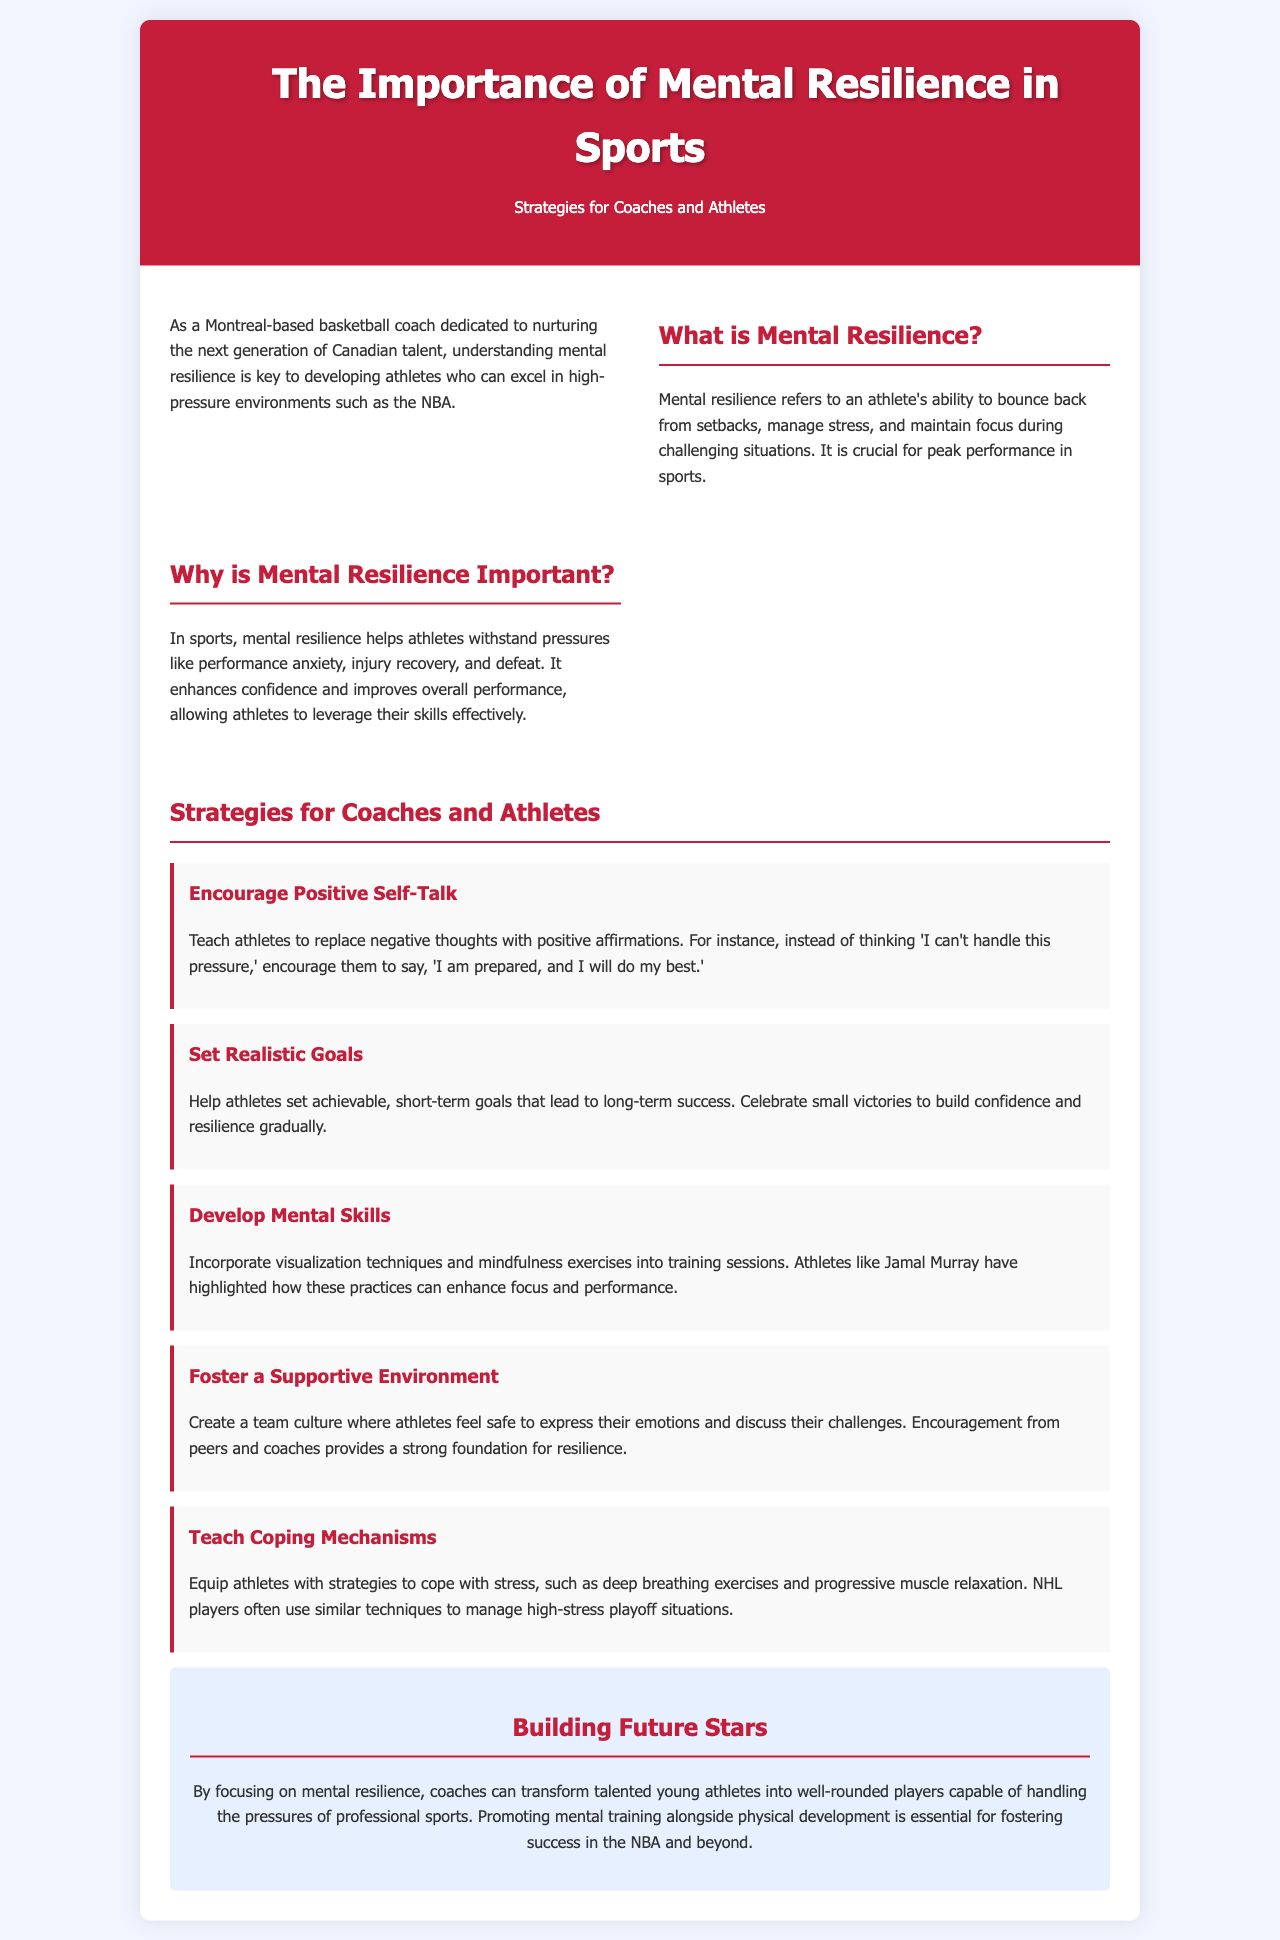What is mental resilience? Mental resilience refers to an athlete's ability to bounce back from setbacks, manage stress, and maintain focus during challenging situations.
Answer: An athlete's ability to bounce back from setbacks Why is mental resilience important? The document states that mental resilience helps athletes withstand pressures like performance anxiety, injury recovery, and defeat.
Answer: To withstand pressures Name one strategy to encourage athletes' resilience. The brochure lists strategies such as encouraging positive self-talk and setting realistic goals.
Answer: Encourage positive self-talk Who is mentioned as an example of using mental skills? The document mentions athletes like Jamal Murray highlighting the benefits of mental skills.
Answer: Jamal Murray What should coaches create to foster resilience? The brochure emphasizes the importance of a supportive environment for fostering resilience among athletes.
Answer: Supportive environment 